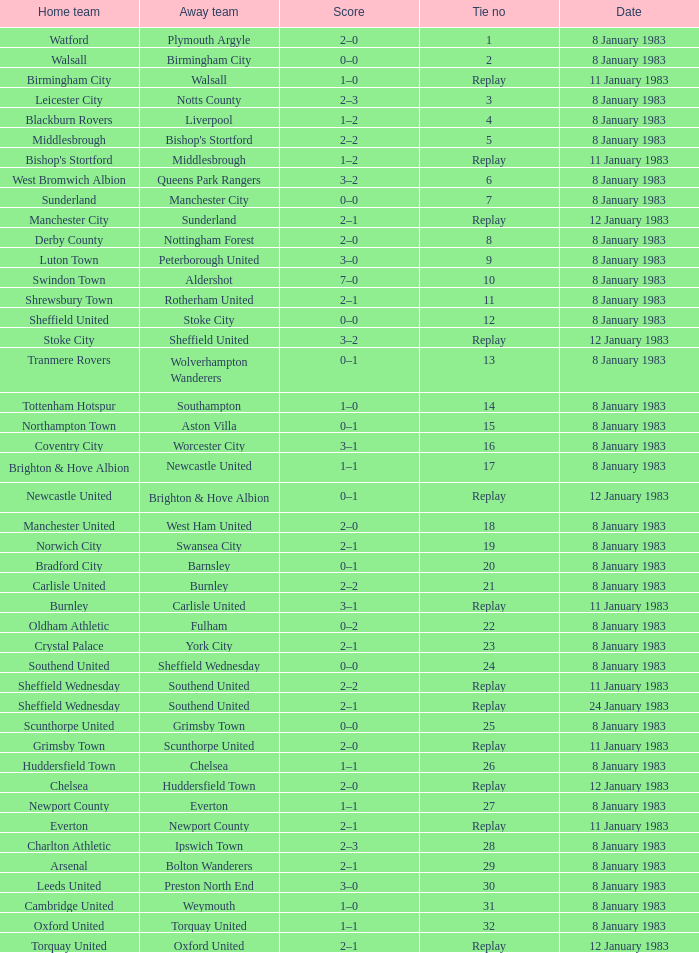What is the name of the away team for Tie #19? Swansea City. Give me the full table as a dictionary. {'header': ['Home team', 'Away team', 'Score', 'Tie no', 'Date'], 'rows': [['Watford', 'Plymouth Argyle', '2–0', '1', '8 January 1983'], ['Walsall', 'Birmingham City', '0–0', '2', '8 January 1983'], ['Birmingham City', 'Walsall', '1–0', 'Replay', '11 January 1983'], ['Leicester City', 'Notts County', '2–3', '3', '8 January 1983'], ['Blackburn Rovers', 'Liverpool', '1–2', '4', '8 January 1983'], ['Middlesbrough', "Bishop's Stortford", '2–2', '5', '8 January 1983'], ["Bishop's Stortford", 'Middlesbrough', '1–2', 'Replay', '11 January 1983'], ['West Bromwich Albion', 'Queens Park Rangers', '3–2', '6', '8 January 1983'], ['Sunderland', 'Manchester City', '0–0', '7', '8 January 1983'], ['Manchester City', 'Sunderland', '2–1', 'Replay', '12 January 1983'], ['Derby County', 'Nottingham Forest', '2–0', '8', '8 January 1983'], ['Luton Town', 'Peterborough United', '3–0', '9', '8 January 1983'], ['Swindon Town', 'Aldershot', '7–0', '10', '8 January 1983'], ['Shrewsbury Town', 'Rotherham United', '2–1', '11', '8 January 1983'], ['Sheffield United', 'Stoke City', '0–0', '12', '8 January 1983'], ['Stoke City', 'Sheffield United', '3–2', 'Replay', '12 January 1983'], ['Tranmere Rovers', 'Wolverhampton Wanderers', '0–1', '13', '8 January 1983'], ['Tottenham Hotspur', 'Southampton', '1–0', '14', '8 January 1983'], ['Northampton Town', 'Aston Villa', '0–1', '15', '8 January 1983'], ['Coventry City', 'Worcester City', '3–1', '16', '8 January 1983'], ['Brighton & Hove Albion', 'Newcastle United', '1–1', '17', '8 January 1983'], ['Newcastle United', 'Brighton & Hove Albion', '0–1', 'Replay', '12 January 1983'], ['Manchester United', 'West Ham United', '2–0', '18', '8 January 1983'], ['Norwich City', 'Swansea City', '2–1', '19', '8 January 1983'], ['Bradford City', 'Barnsley', '0–1', '20', '8 January 1983'], ['Carlisle United', 'Burnley', '2–2', '21', '8 January 1983'], ['Burnley', 'Carlisle United', '3–1', 'Replay', '11 January 1983'], ['Oldham Athletic', 'Fulham', '0–2', '22', '8 January 1983'], ['Crystal Palace', 'York City', '2–1', '23', '8 January 1983'], ['Southend United', 'Sheffield Wednesday', '0–0', '24', '8 January 1983'], ['Sheffield Wednesday', 'Southend United', '2–2', 'Replay', '11 January 1983'], ['Sheffield Wednesday', 'Southend United', '2–1', 'Replay', '24 January 1983'], ['Scunthorpe United', 'Grimsby Town', '0–0', '25', '8 January 1983'], ['Grimsby Town', 'Scunthorpe United', '2–0', 'Replay', '11 January 1983'], ['Huddersfield Town', 'Chelsea', '1–1', '26', '8 January 1983'], ['Chelsea', 'Huddersfield Town', '2–0', 'Replay', '12 January 1983'], ['Newport County', 'Everton', '1–1', '27', '8 January 1983'], ['Everton', 'Newport County', '2–1', 'Replay', '11 January 1983'], ['Charlton Athletic', 'Ipswich Town', '2–3', '28', '8 January 1983'], ['Arsenal', 'Bolton Wanderers', '2–1', '29', '8 January 1983'], ['Leeds United', 'Preston North End', '3–0', '30', '8 January 1983'], ['Cambridge United', 'Weymouth', '1–0', '31', '8 January 1983'], ['Oxford United', 'Torquay United', '1–1', '32', '8 January 1983'], ['Torquay United', 'Oxford United', '2–1', 'Replay', '12 January 1983']]} 